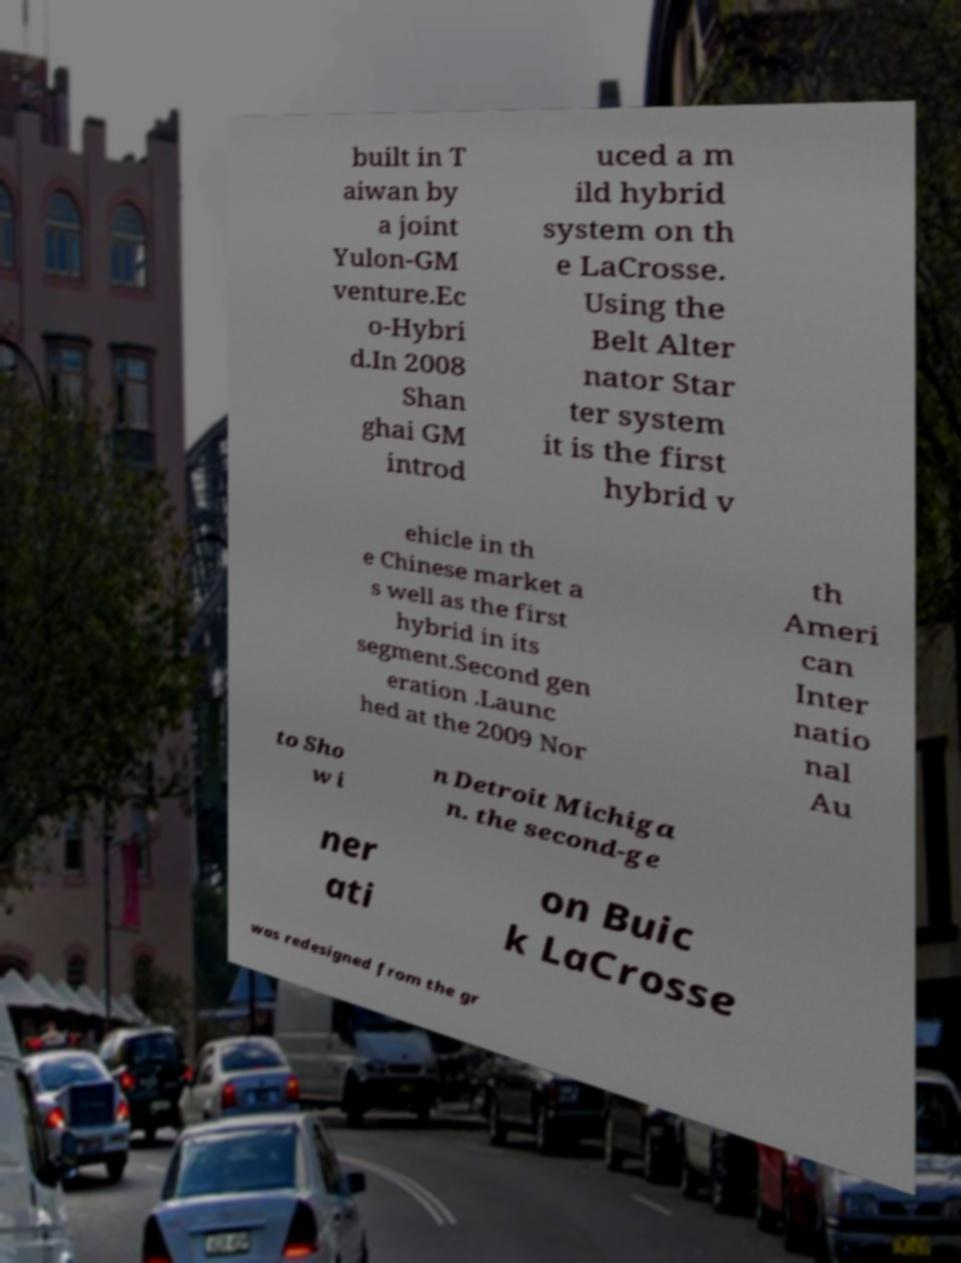Please identify and transcribe the text found in this image. built in T aiwan by a joint Yulon-GM venture.Ec o-Hybri d.In 2008 Shan ghai GM introd uced a m ild hybrid system on th e LaCrosse. Using the Belt Alter nator Star ter system it is the first hybrid v ehicle in th e Chinese market a s well as the first hybrid in its segment.Second gen eration .Launc hed at the 2009 Nor th Ameri can Inter natio nal Au to Sho w i n Detroit Michiga n. the second-ge ner ati on Buic k LaCrosse was redesigned from the gr 